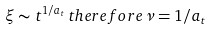Convert formula to latex. <formula><loc_0><loc_0><loc_500><loc_500>\xi \sim t ^ { 1 / a _ { t } } \, t h e r e f o r e \, \nu = 1 / a _ { t }</formula> 